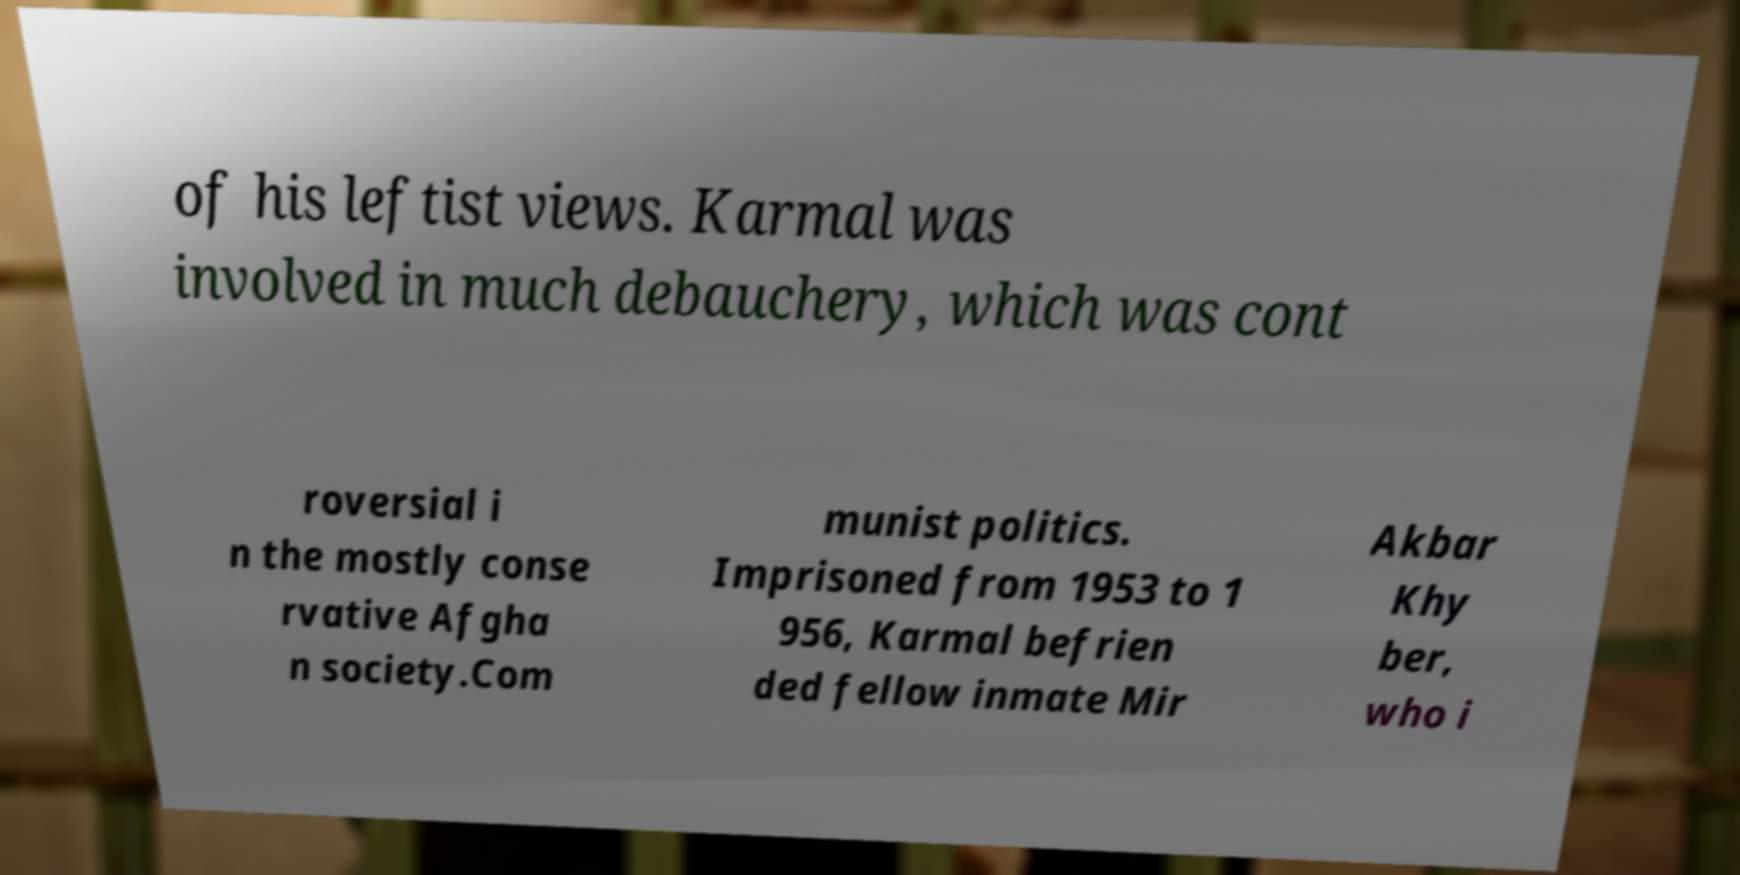Please identify and transcribe the text found in this image. of his leftist views. Karmal was involved in much debauchery, which was cont roversial i n the mostly conse rvative Afgha n society.Com munist politics. Imprisoned from 1953 to 1 956, Karmal befrien ded fellow inmate Mir Akbar Khy ber, who i 